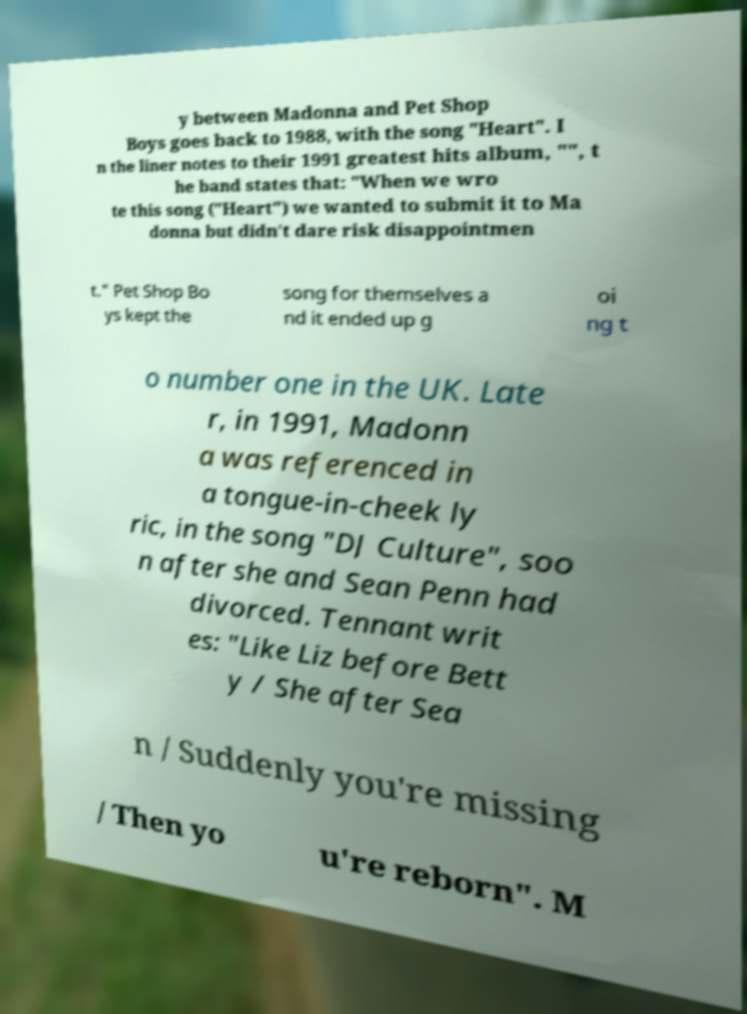Please identify and transcribe the text found in this image. y between Madonna and Pet Shop Boys goes back to 1988, with the song "Heart". I n the liner notes to their 1991 greatest hits album, "", t he band states that: "When we wro te this song ("Heart") we wanted to submit it to Ma donna but didn't dare risk disappointmen t." Pet Shop Bo ys kept the song for themselves a nd it ended up g oi ng t o number one in the UK. Late r, in 1991, Madonn a was referenced in a tongue-in-cheek ly ric, in the song "DJ Culture", soo n after she and Sean Penn had divorced. Tennant writ es: "Like Liz before Bett y / She after Sea n / Suddenly you're missing / Then yo u're reborn". M 